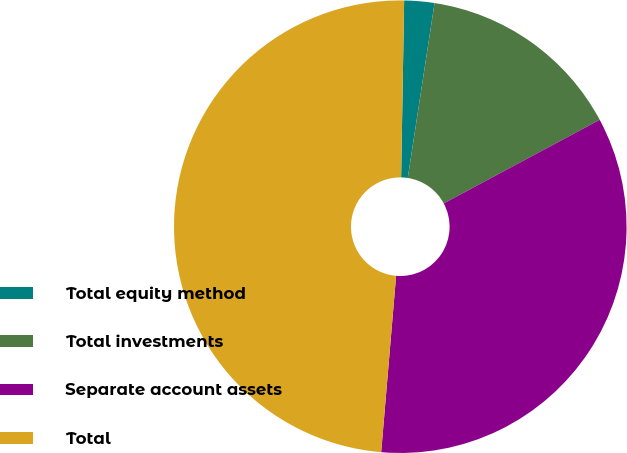Convert chart. <chart><loc_0><loc_0><loc_500><loc_500><pie_chart><fcel>Total equity method<fcel>Total investments<fcel>Separate account assets<fcel>Total<nl><fcel>2.15%<fcel>14.75%<fcel>34.18%<fcel>48.93%<nl></chart> 